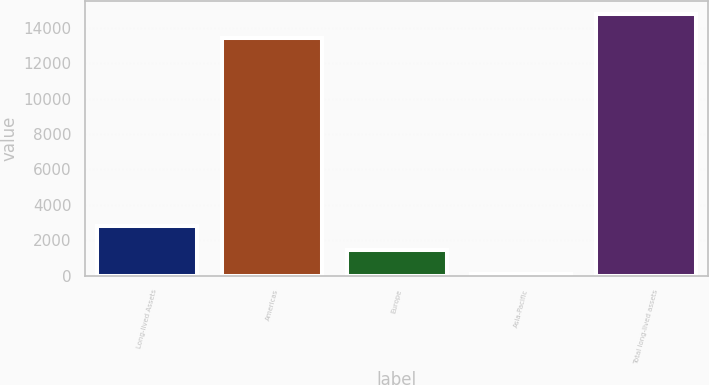<chart> <loc_0><loc_0><loc_500><loc_500><bar_chart><fcel>Long-lived Assets<fcel>Americas<fcel>Europe<fcel>Asia-Pacific<fcel>Total long-lived assets<nl><fcel>2807.4<fcel>13424<fcel>1448.7<fcel>90<fcel>14782.7<nl></chart> 